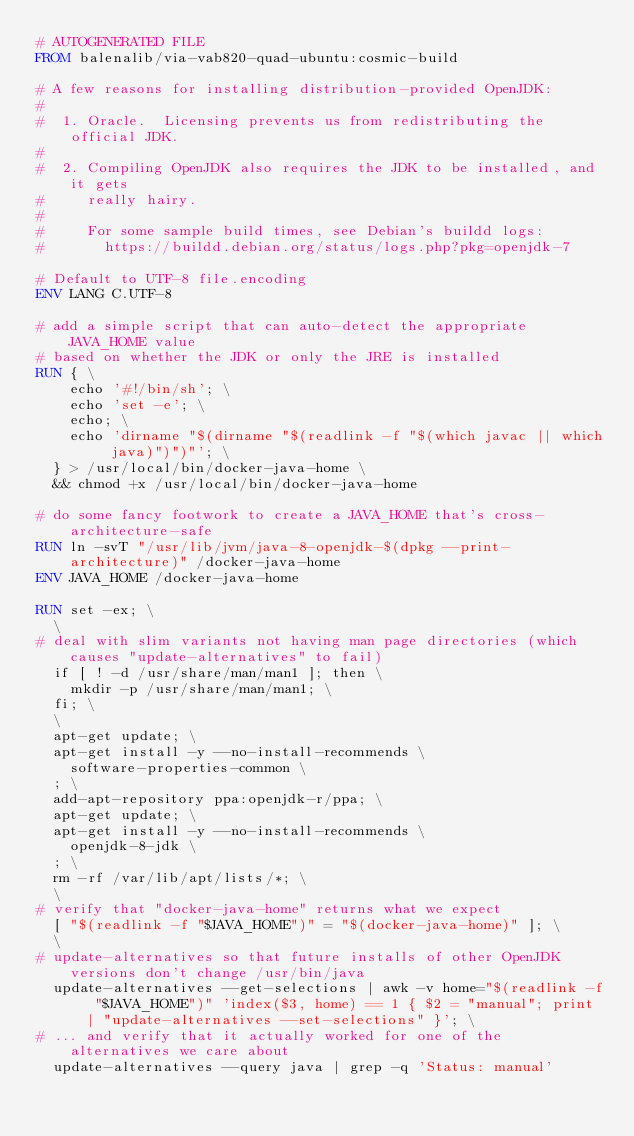<code> <loc_0><loc_0><loc_500><loc_500><_Dockerfile_># AUTOGENERATED FILE
FROM balenalib/via-vab820-quad-ubuntu:cosmic-build

# A few reasons for installing distribution-provided OpenJDK:
#
#  1. Oracle.  Licensing prevents us from redistributing the official JDK.
#
#  2. Compiling OpenJDK also requires the JDK to be installed, and it gets
#     really hairy.
#
#     For some sample build times, see Debian's buildd logs:
#       https://buildd.debian.org/status/logs.php?pkg=openjdk-7

# Default to UTF-8 file.encoding
ENV LANG C.UTF-8

# add a simple script that can auto-detect the appropriate JAVA_HOME value
# based on whether the JDK or only the JRE is installed
RUN { \
		echo '#!/bin/sh'; \
		echo 'set -e'; \
		echo; \
		echo 'dirname "$(dirname "$(readlink -f "$(which javac || which java)")")"'; \
	} > /usr/local/bin/docker-java-home \
	&& chmod +x /usr/local/bin/docker-java-home

# do some fancy footwork to create a JAVA_HOME that's cross-architecture-safe
RUN ln -svT "/usr/lib/jvm/java-8-openjdk-$(dpkg --print-architecture)" /docker-java-home
ENV JAVA_HOME /docker-java-home

RUN set -ex; \
	\
# deal with slim variants not having man page directories (which causes "update-alternatives" to fail)
	if [ ! -d /usr/share/man/man1 ]; then \
		mkdir -p /usr/share/man/man1; \
	fi; \
	\
	apt-get update; \
	apt-get install -y --no-install-recommends \
		software-properties-common \
	; \
	add-apt-repository ppa:openjdk-r/ppa; \
	apt-get update; \
	apt-get install -y --no-install-recommends \
		openjdk-8-jdk \
	; \
	rm -rf /var/lib/apt/lists/*; \
	\
# verify that "docker-java-home" returns what we expect
	[ "$(readlink -f "$JAVA_HOME")" = "$(docker-java-home)" ]; \
	\
# update-alternatives so that future installs of other OpenJDK versions don't change /usr/bin/java
	update-alternatives --get-selections | awk -v home="$(readlink -f "$JAVA_HOME")" 'index($3, home) == 1 { $2 = "manual"; print | "update-alternatives --set-selections" }'; \
# ... and verify that it actually worked for one of the alternatives we care about
	update-alternatives --query java | grep -q 'Status: manual'
</code> 